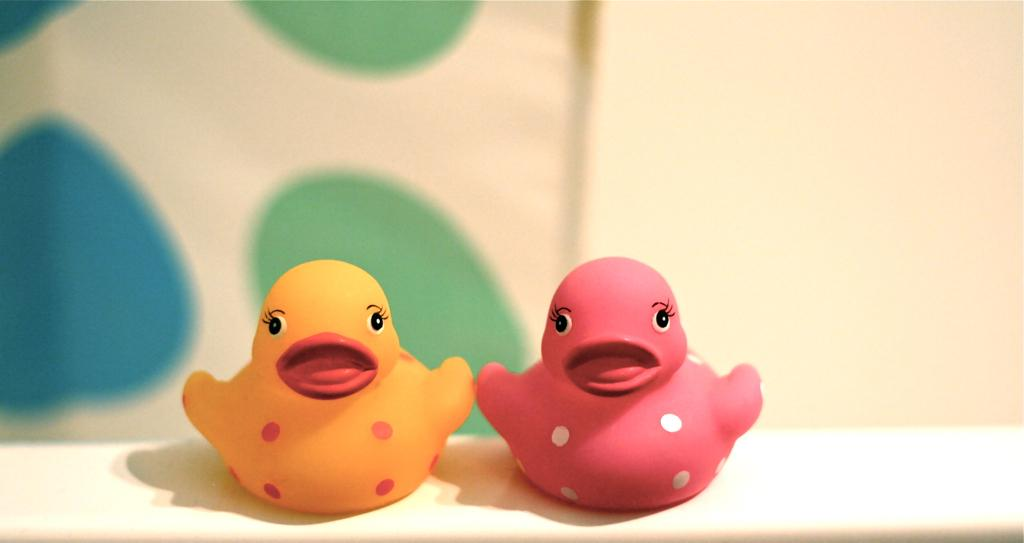How many toys are visible in the image? There are two toys in the image. What colors are the toys? One toy is pink, and the other is yellow. Where are the toys placed? The toys are placed on a white desk. What can be seen in the background of the image? There is a white wall in the background of the image. What is the weight of the nation represented by the toys in the image? There is no nation represented by the toys in the image, and therefore no weight can be assigned to it. 